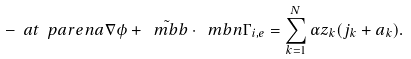Convert formula to latex. <formula><loc_0><loc_0><loc_500><loc_500>- \ a t { \ p a r e n { a \nabla \phi + \tilde { \ m b { b } } } \cdot \ m b { n } } { \Gamma _ { i , e } } = \sum _ { k = 1 } ^ { N } \alpha z _ { k } ( j _ { k } + a _ { k } ) .</formula> 